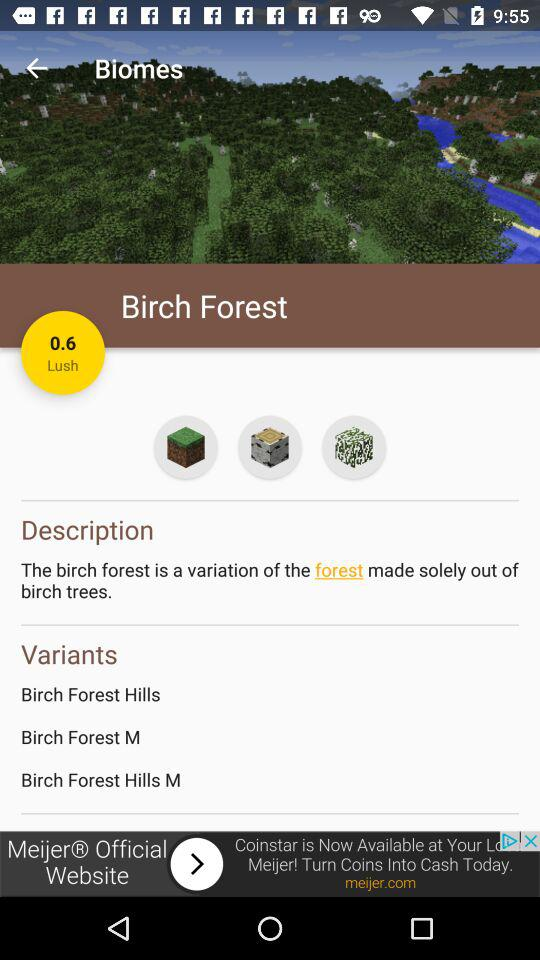How many variants are there of the birch forest biome?
Answer the question using a single word or phrase. 3 